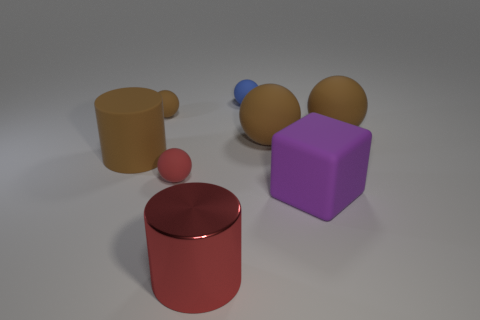There is a blue matte object; does it have the same shape as the small object in front of the large rubber cylinder?
Your response must be concise. Yes. What number of red objects are both behind the purple rubber cube and in front of the large purple thing?
Offer a terse response. 0. What number of cyan things are metallic objects or big rubber balls?
Keep it short and to the point. 0. There is a tiny matte thing in front of the rubber cylinder; is its color the same as the large rubber object left of the small blue rubber thing?
Ensure brevity in your answer.  No. There is a tiny matte object that is on the right side of the big cylinder on the right side of the big brown object to the left of the red matte thing; what is its color?
Provide a succinct answer. Blue. There is a purple cube that is in front of the small blue ball; are there any blue matte objects that are in front of it?
Offer a very short reply. No. Does the large matte thing that is in front of the brown cylinder have the same shape as the blue thing?
Make the answer very short. No. Are there any other things that are the same shape as the small brown rubber object?
Keep it short and to the point. Yes. How many cylinders are either large purple rubber things or blue objects?
Ensure brevity in your answer.  0. How many red balls are there?
Provide a short and direct response. 1. 